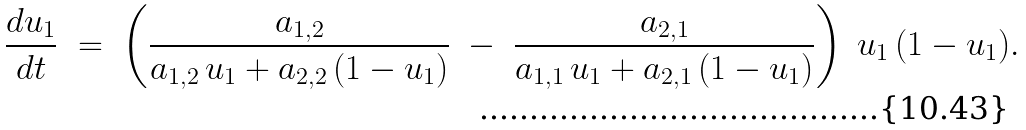<formula> <loc_0><loc_0><loc_500><loc_500>\frac { d u _ { 1 } } { d t } \ = \ \left ( \frac { a _ { 1 , 2 } } { a _ { 1 , 2 } \, u _ { 1 } + a _ { 2 , 2 } \, ( 1 - u _ { 1 } ) } \ - \ \frac { a _ { 2 , 1 } } { a _ { 1 , 1 } \, u _ { 1 } + a _ { 2 , 1 } \, ( 1 - u _ { 1 } ) } \right ) \ u _ { 1 } \, ( 1 - u _ { 1 } ) .</formula> 